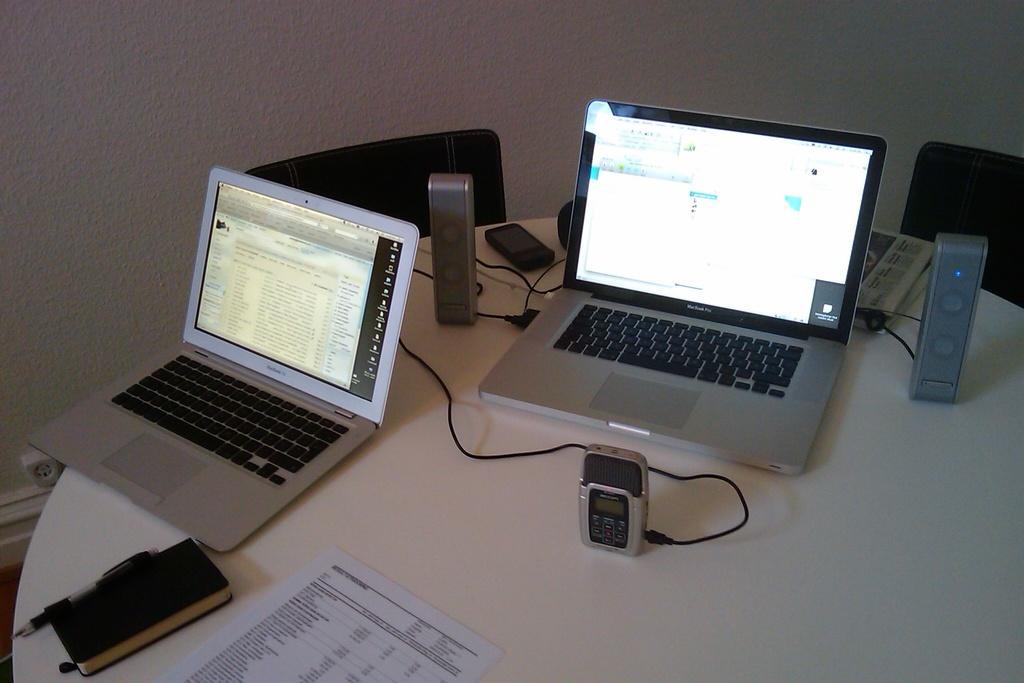Please provide a concise description of this image. In this picture we can see a table and on the table, there are laptops, cables, a paper, pen and some objects. Behind the table, there are chairs and a wall. On the left side of the image, there is an object attached to the wall. 